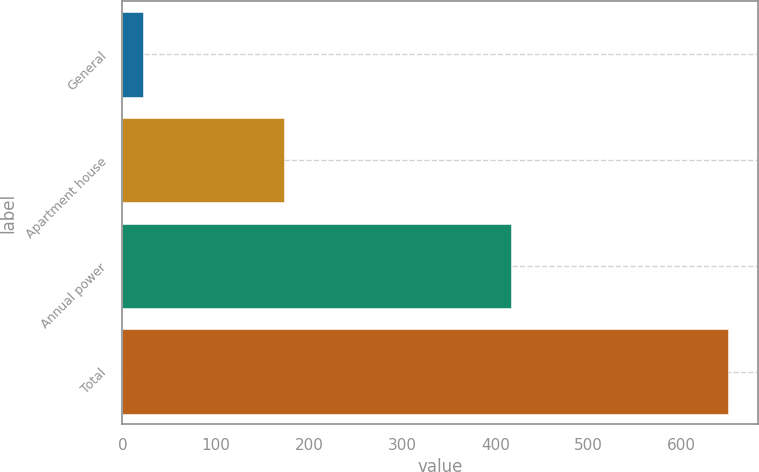Convert chart to OTSL. <chart><loc_0><loc_0><loc_500><loc_500><bar_chart><fcel>General<fcel>Apartment house<fcel>Annual power<fcel>Total<nl><fcel>22<fcel>173<fcel>417<fcel>649<nl></chart> 